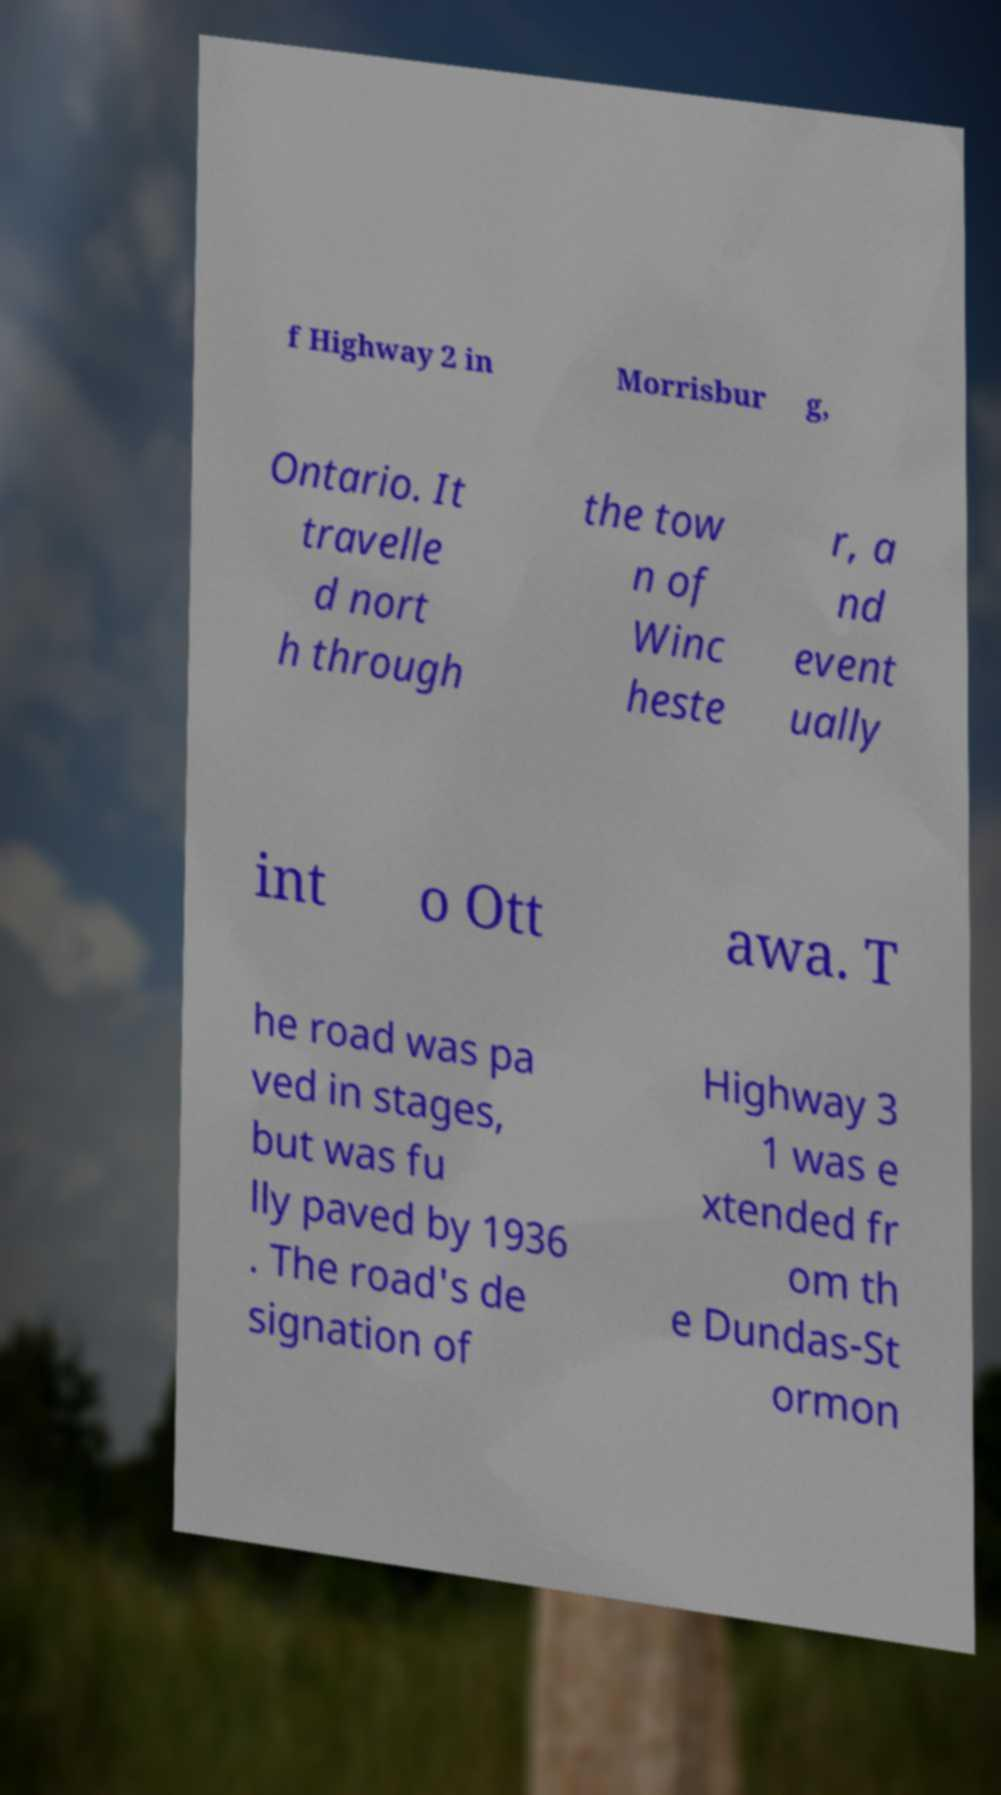Please read and relay the text visible in this image. What does it say? f Highway 2 in Morrisbur g, Ontario. It travelle d nort h through the tow n of Winc heste r, a nd event ually int o Ott awa. T he road was pa ved in stages, but was fu lly paved by 1936 . The road's de signation of Highway 3 1 was e xtended fr om th e Dundas-St ormon 